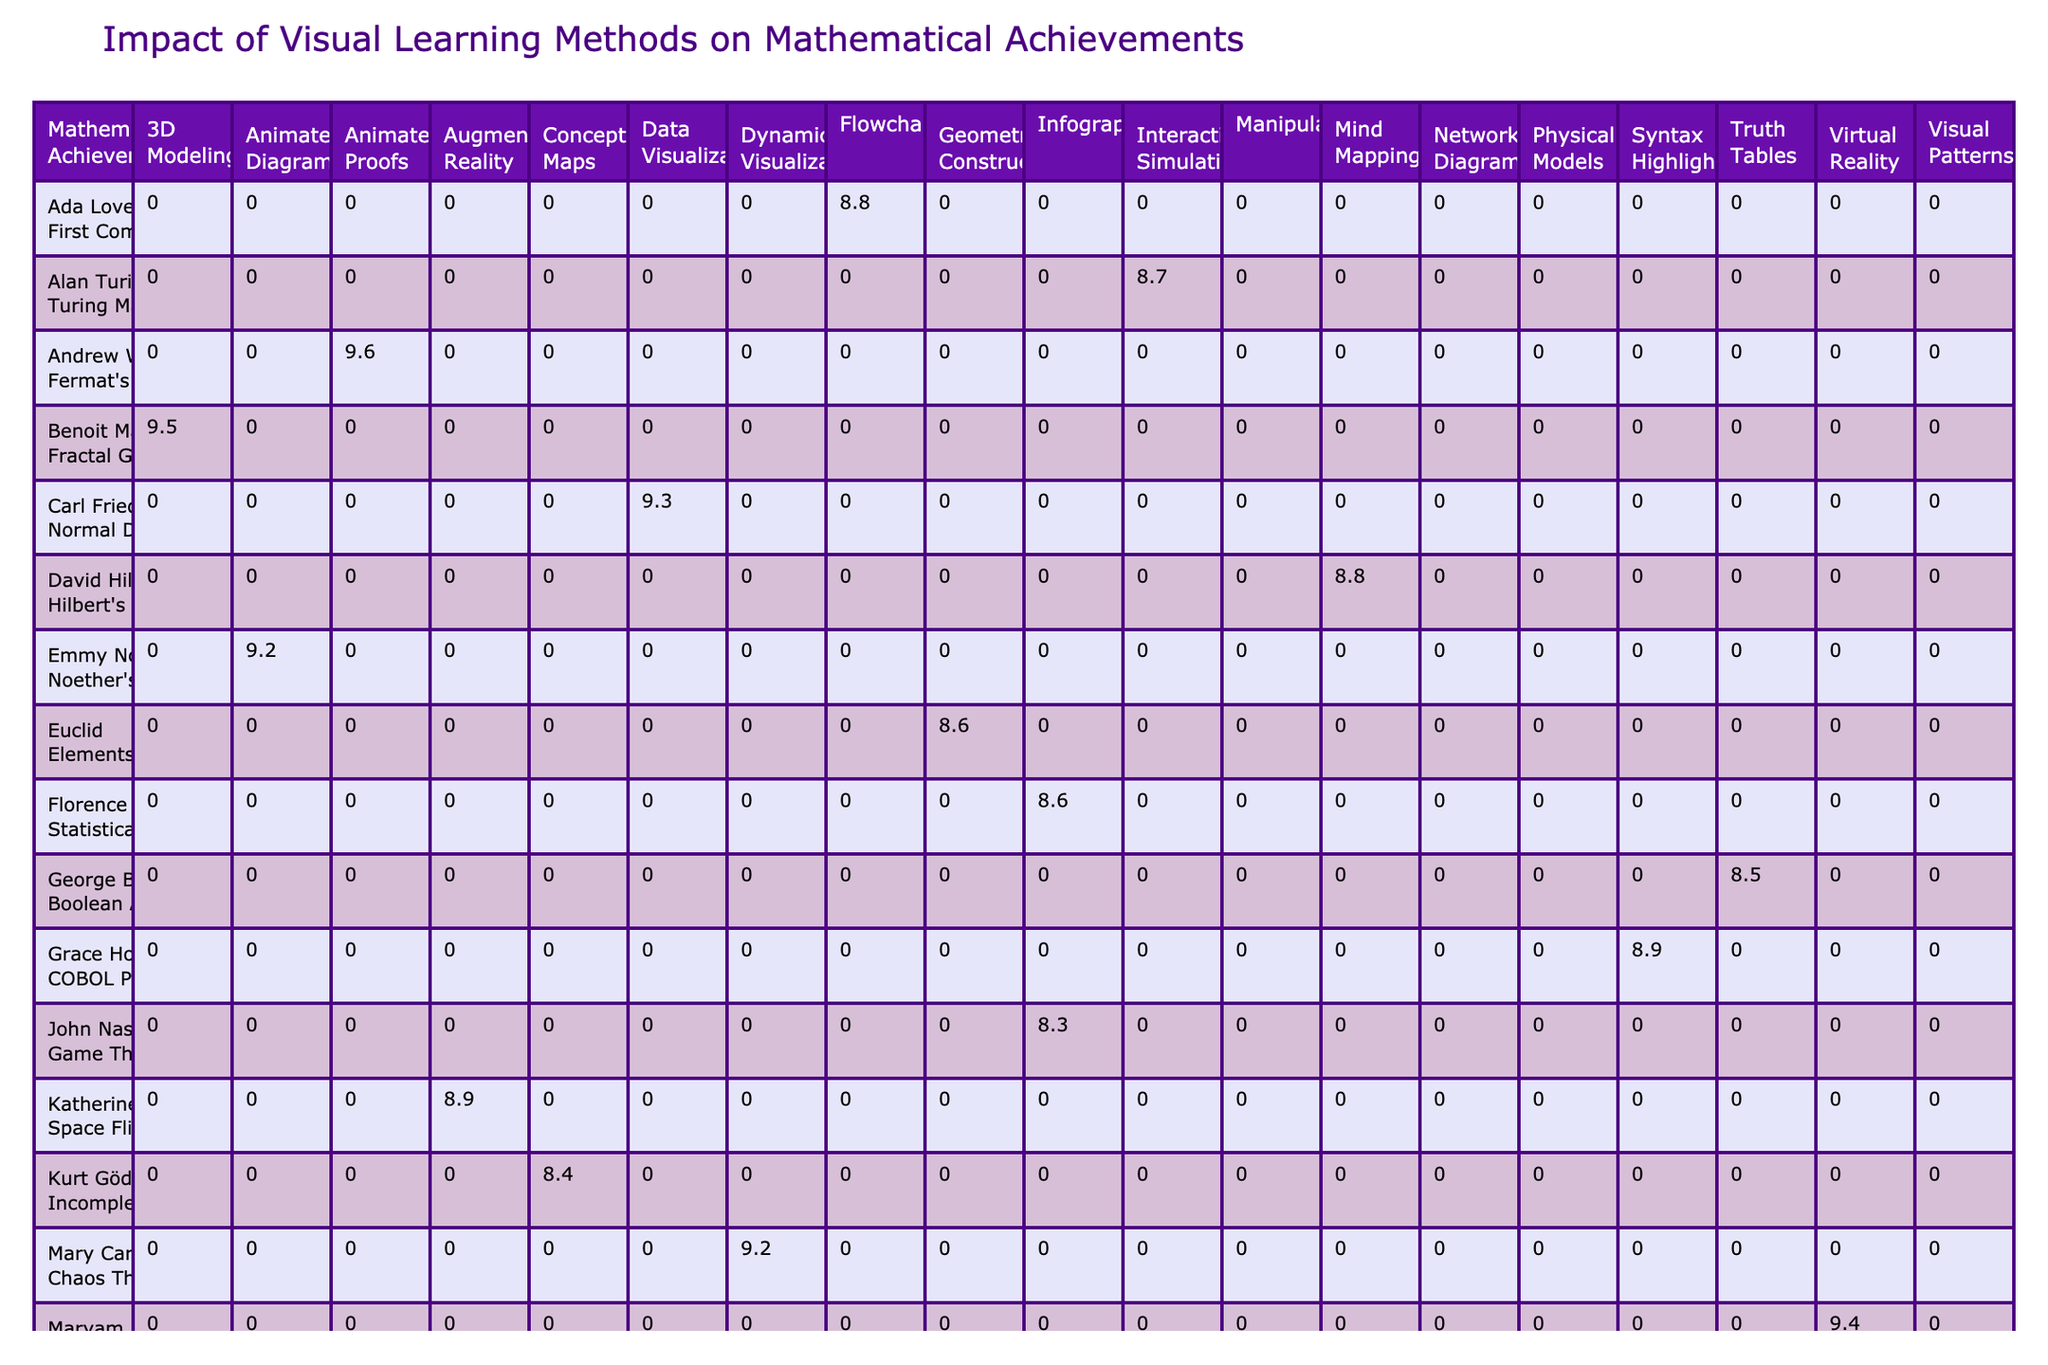What is the highest impact score achieved by a mathematician using animated diagrams? The table shows that Emmy Noether achieved an impact score of 9.2 using animated diagrams, which is the highest score within that category.
Answer: 9.2 Which visual learning method has the lowest impact score for mathematical achievements? Upon reviewing the table, the visual learning method with the lowest impact score is 'Truth Tables' at 8.5.
Answer: 8.5 What is the average impact score of all achievements mentioned under the category of 'All Ages'? To find the average, we take the impact scores of the entries that fall under 'All Ages', which are: 9.5, 9.0, 9.4, and 9.1. Adding these gives us 37.0, and since there are 4 items, we calculate 37.0 / 4 = 9.25.
Answer: 9.25 Does any mathematician have a higher impact score for interactive simulations compared to the highest score from animated proofs? The highest impact score for animated proofs is 9.6 from Andrew Wiles. The only associated impact score for interactive simulations is 8.7 from Alan Turing, which is lower than 9.6. Therefore, no mathematician scores higher.
Answer: No Which visual learning method has been associated with mathematicians from the age group of teenagers that has the highest impact score? The table lists two entries under the age group of teenagers: "Space Flight Calculations" and "Pythagorean Theorem" with scores of 8.9 and 8.7 respectively. Hence, 'Space Flight Calculations' with an impact score of 8.9 has the highest in this group.
Answer: 8.9 What is the total number of unique visual learning methods represented in the table? The table lists a total of 12 unique visual learning methods, including 'Animated Diagrams', 'Interactive Simulations', '3D Modeling', and others. Counting these gives us 12 methods.
Answer: 12 What is the impact score difference between the highest score for 'Virtual Reality' and the lowest score for 'Concept Maps'? The highest score for 'Virtual Reality' is 9.4, and the lowest score for 'Concept Maps' is 8.4. Therefore, the difference is 9.4 - 8.4 = 1.0.
Answer: 1.0 How many mathematicians published their work in 2019 and what was the average impact score of their achievements? Reviewing the table, the mathematicians who published work in 2019 are Alan Turing, Paul Erdős, and Mary Mirzakhani with impact scores of 8.7, 9.0, and 9.4 respectively. Adding these scores gives 8.7 + 9.0 + 9.4 = 27.1 and dividing by 3 yields an average score of 9.0.
Answer: 9.0 Which achievement under the category of 'Adults' has the lowest impact score? The table shows that the achievement under the category of 'Adults' with the lowest impact score is 'Game Theory' with a score of 8.3 achieved by John Nash.
Answer: 8.3 